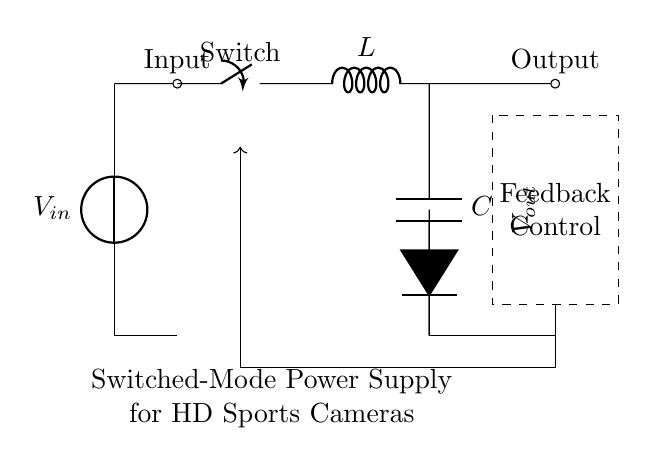What is the main purpose of this circuit? The purpose of the circuit is to regulate voltage for high-definition sports cameras by converting input voltage to a stable output voltage using a switched-mode power supply.
Answer: Regulating voltage What component provides the current flow? The switch allows or interrupts current flow when opened or closed, controlling the current in the circuit.
Answer: Switch What type of circuit is represented here? This is a switched-mode power supply circuit designed to efficiently convert and regulate voltage.
Answer: Switched-mode power supply What is the function of the inductor in this circuit? The inductor stores energy when current flows through it, contributing to the conversion process and smoothing out current pulses in the switched-mode operation.
Answer: Energy storage How many main components are visible in the circuit? There are four main components: a switch, an inductor, a diode, and a capacitor.
Answer: Four What voltage is being outputted in this circuit? The output voltage is denoted as V out, indicating it is regulated and does not have a specific numeric value given in the circuit.
Answer: V out What is the role of the feedback control? The feedback control monitors the output voltage and adjusts the switching to maintain a consistent output voltage despite variations in the input or load conditions.
Answer: Monitoring output 